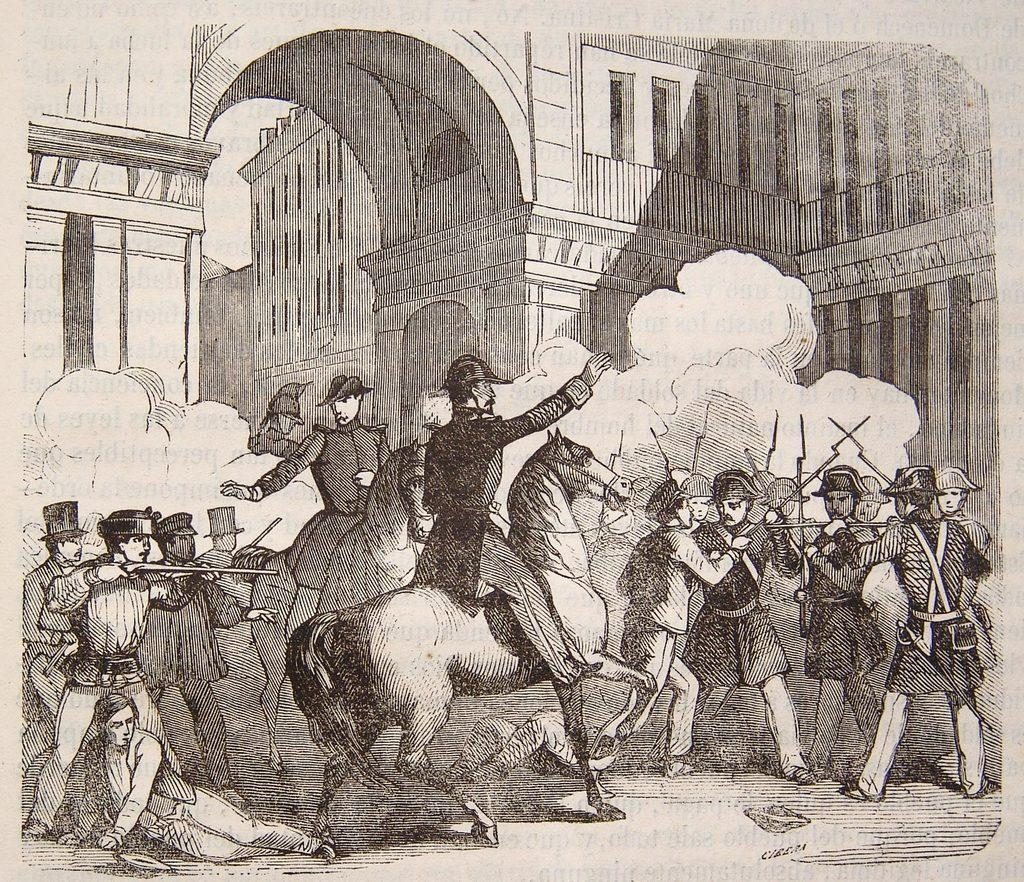What is the main subject of the image? The image contains a painting. What is happening in the painting? The painting depicts persons riding horses. Are there any additional objects or elements in the painting? Some persons in the painting are holding weapons. What can be seen in the background of the painting? There is a fort visible in the background of the painting. What type of bedroom furniture can be seen in the image? There is no bedroom furniture present in the image, as it features a painting of persons riding horses with a fort in the background. What tools might a carpenter use in the image? There is no carpenter or carpentry tools present in the image; it is a painting of persons riding horses with a fort in the background. 